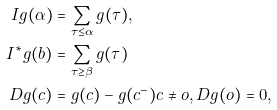<formula> <loc_0><loc_0><loc_500><loc_500>I g ( \alpha ) & = \sum _ { \tau \leq \alpha } g ( \tau ) , \\ I ^ { \ast } g ( b ) & = \sum _ { \tau \geq \beta } g ( \tau ) \\ D g ( c ) & = g ( c ) - g ( c ^ { - } ) c \neq o , D g ( o ) = 0 ,</formula> 